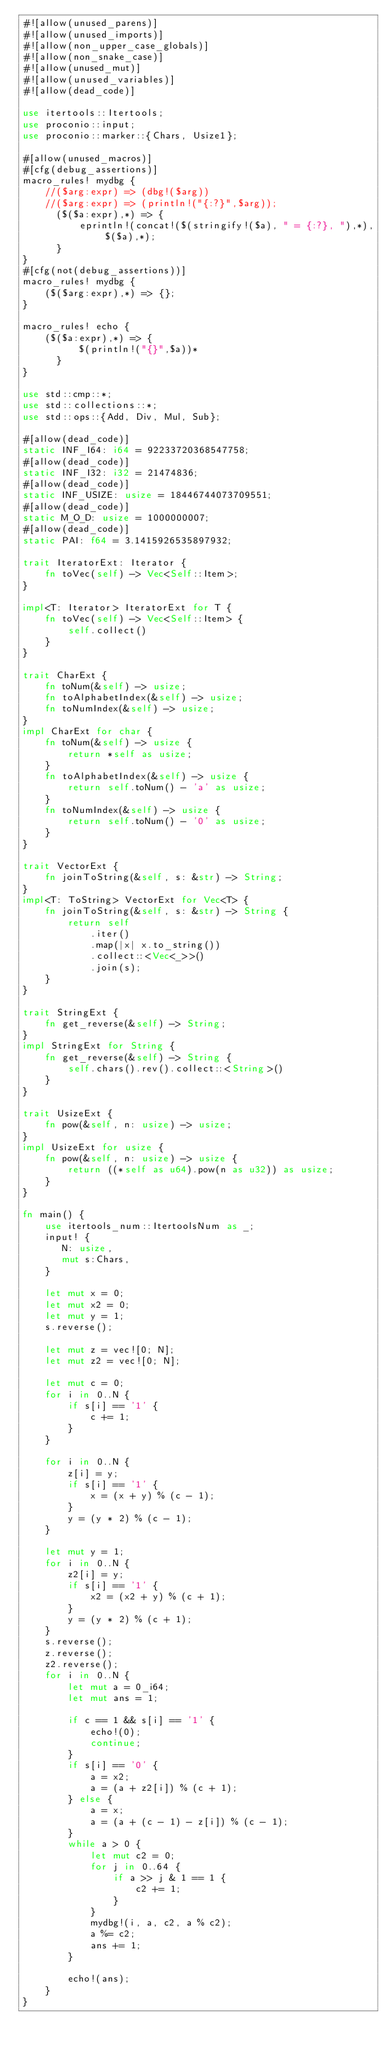<code> <loc_0><loc_0><loc_500><loc_500><_Rust_>#![allow(unused_parens)]
#![allow(unused_imports)]
#![allow(non_upper_case_globals)]
#![allow(non_snake_case)]
#![allow(unused_mut)]
#![allow(unused_variables)]
#![allow(dead_code)]

use itertools::Itertools;
use proconio::input;
use proconio::marker::{Chars, Usize1};

#[allow(unused_macros)]
#[cfg(debug_assertions)]
macro_rules! mydbg {
    //($arg:expr) => (dbg!($arg))
    //($arg:expr) => (println!("{:?}",$arg));
      ($($a:expr),*) => {
          eprintln!(concat!($(stringify!($a), " = {:?}, "),*), $($a),*);
      }
}
#[cfg(not(debug_assertions))]
macro_rules! mydbg {
    ($($arg:expr),*) => {};
}

macro_rules! echo {
    ($($a:expr),*) => {
          $(println!("{}",$a))*
      }
}

use std::cmp::*;
use std::collections::*;
use std::ops::{Add, Div, Mul, Sub};

#[allow(dead_code)]
static INF_I64: i64 = 92233720368547758;
#[allow(dead_code)]
static INF_I32: i32 = 21474836;
#[allow(dead_code)]
static INF_USIZE: usize = 18446744073709551;
#[allow(dead_code)]
static M_O_D: usize = 1000000007;
#[allow(dead_code)]
static PAI: f64 = 3.1415926535897932;

trait IteratorExt: Iterator {
    fn toVec(self) -> Vec<Self::Item>;
}

impl<T: Iterator> IteratorExt for T {
    fn toVec(self) -> Vec<Self::Item> {
        self.collect()
    }
}

trait CharExt {
    fn toNum(&self) -> usize;
    fn toAlphabetIndex(&self) -> usize;
    fn toNumIndex(&self) -> usize;
}
impl CharExt for char {
    fn toNum(&self) -> usize {
        return *self as usize;
    }
    fn toAlphabetIndex(&self) -> usize {
        return self.toNum() - 'a' as usize;
    }
    fn toNumIndex(&self) -> usize {
        return self.toNum() - '0' as usize;
    }
}

trait VectorExt {
    fn joinToString(&self, s: &str) -> String;
}
impl<T: ToString> VectorExt for Vec<T> {
    fn joinToString(&self, s: &str) -> String {
        return self
            .iter()
            .map(|x| x.to_string())
            .collect::<Vec<_>>()
            .join(s);
    }
}

trait StringExt {
    fn get_reverse(&self) -> String;
}
impl StringExt for String {
    fn get_reverse(&self) -> String {
        self.chars().rev().collect::<String>()
    }
}

trait UsizeExt {
    fn pow(&self, n: usize) -> usize;
}
impl UsizeExt for usize {
    fn pow(&self, n: usize) -> usize {
        return ((*self as u64).pow(n as u32)) as usize;
    }
}

fn main() {
    use itertools_num::ItertoolsNum as _;
    input! {
       N: usize,
       mut s:Chars,
    }

    let mut x = 0;
    let mut x2 = 0;
    let mut y = 1;
    s.reverse();

    let mut z = vec![0; N];
    let mut z2 = vec![0; N];

    let mut c = 0;
    for i in 0..N {
        if s[i] == '1' {
            c += 1;
        }
    }

    for i in 0..N {
        z[i] = y;
        if s[i] == '1' {
            x = (x + y) % (c - 1);
        }
        y = (y * 2) % (c - 1);
    }

    let mut y = 1;
    for i in 0..N {
        z2[i] = y;
        if s[i] == '1' {
            x2 = (x2 + y) % (c + 1);
        }
        y = (y * 2) % (c + 1);
    }
    s.reverse();
    z.reverse();
    z2.reverse();
    for i in 0..N {
        let mut a = 0_i64;
        let mut ans = 1;

        if c == 1 && s[i] == '1' {
            echo!(0);
            continue;
        }
        if s[i] == '0' {
            a = x2;
            a = (a + z2[i]) % (c + 1);
        } else {
            a = x;
            a = (a + (c - 1) - z[i]) % (c - 1);
        }
        while a > 0 {
            let mut c2 = 0;
            for j in 0..64 {
                if a >> j & 1 == 1 {
                    c2 += 1;
                }
            }
            mydbg!(i, a, c2, a % c2);
            a %= c2;
            ans += 1;
        }

        echo!(ans);
    }
}
</code> 